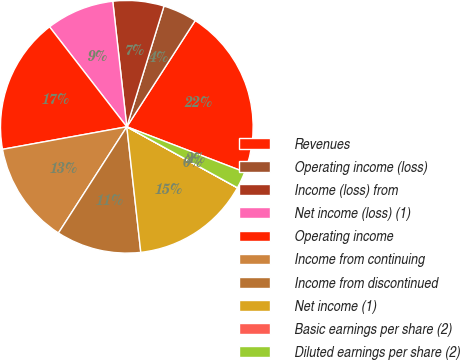Convert chart. <chart><loc_0><loc_0><loc_500><loc_500><pie_chart><fcel>Revenues<fcel>Operating income (loss)<fcel>Income (loss) from<fcel>Net income (loss) (1)<fcel>Operating income<fcel>Income from continuing<fcel>Income from discontinued<fcel>Net income (1)<fcel>Basic earnings per share (2)<fcel>Diluted earnings per share (2)<nl><fcel>21.73%<fcel>4.35%<fcel>6.53%<fcel>8.7%<fcel>17.38%<fcel>13.04%<fcel>10.87%<fcel>15.21%<fcel>0.01%<fcel>2.18%<nl></chart> 